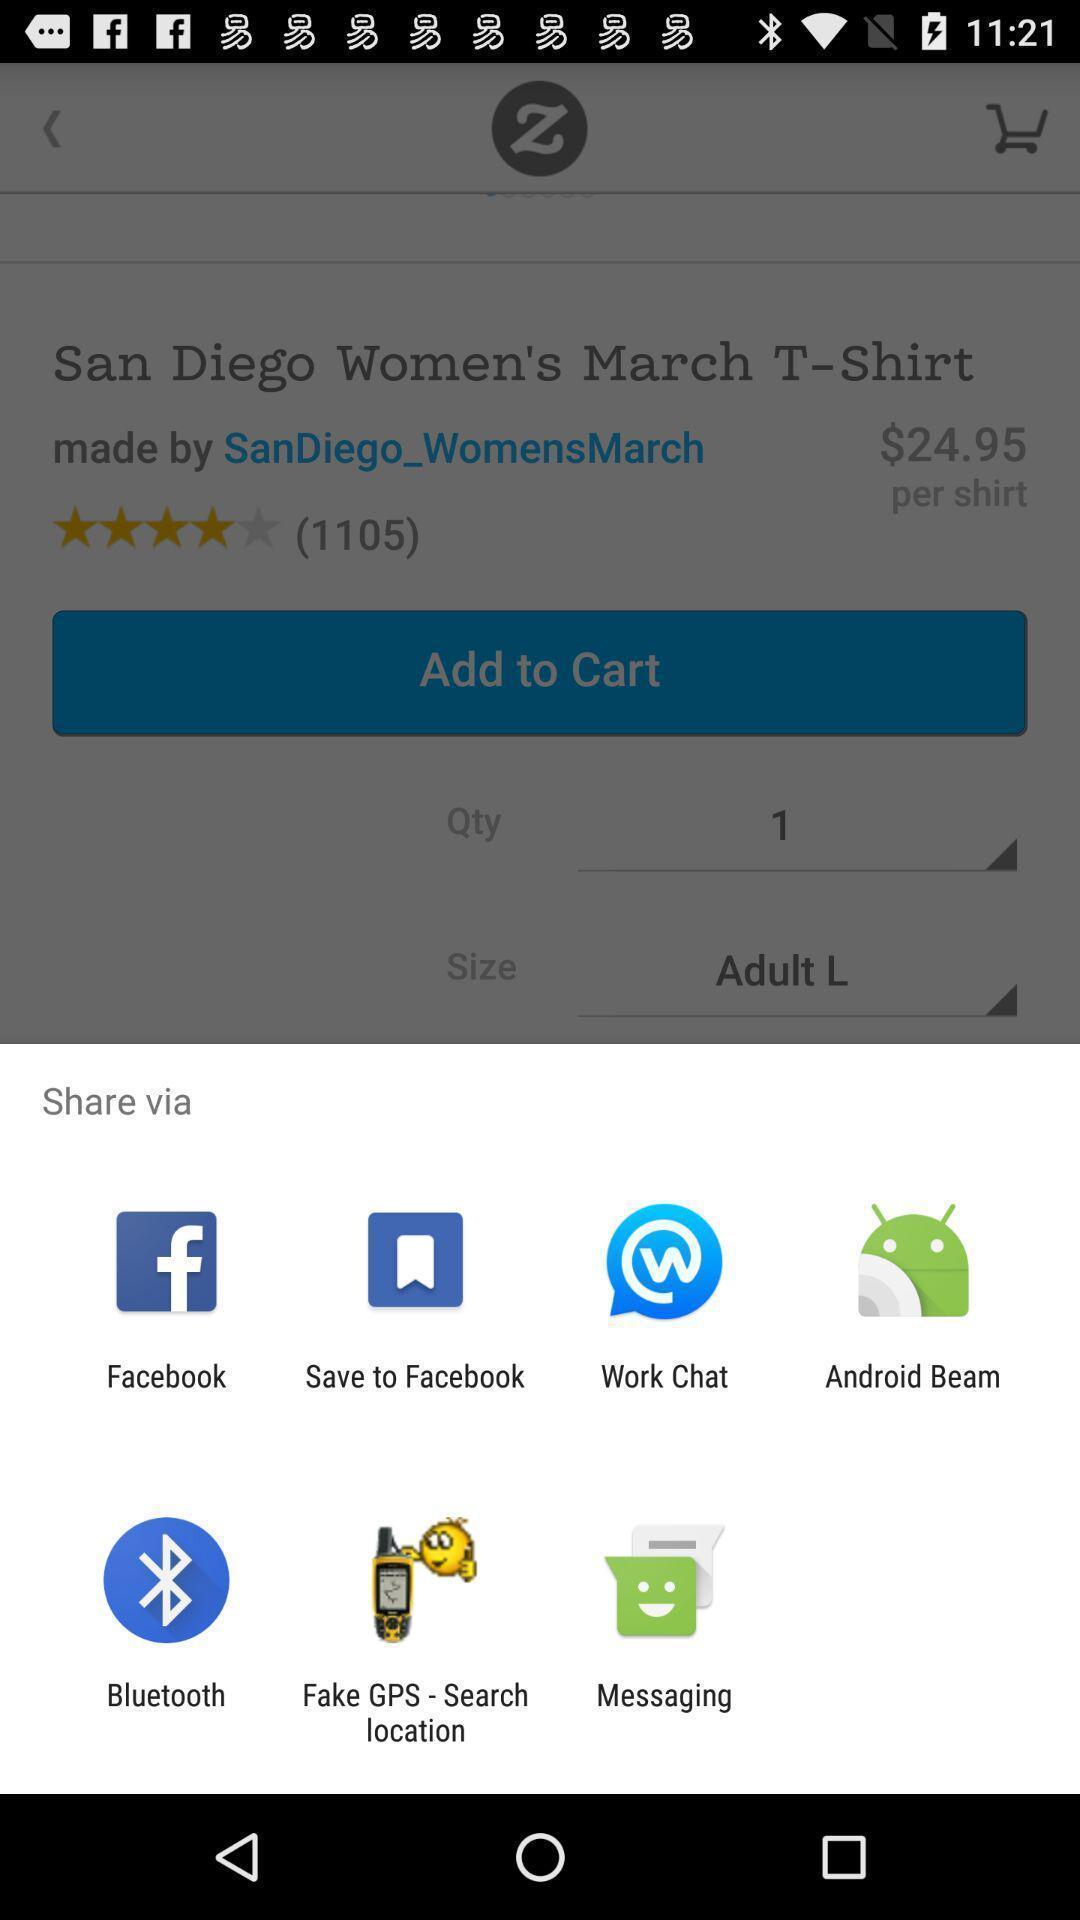What details can you identify in this image? Popup showing few sharing options with icons in shopping app. 